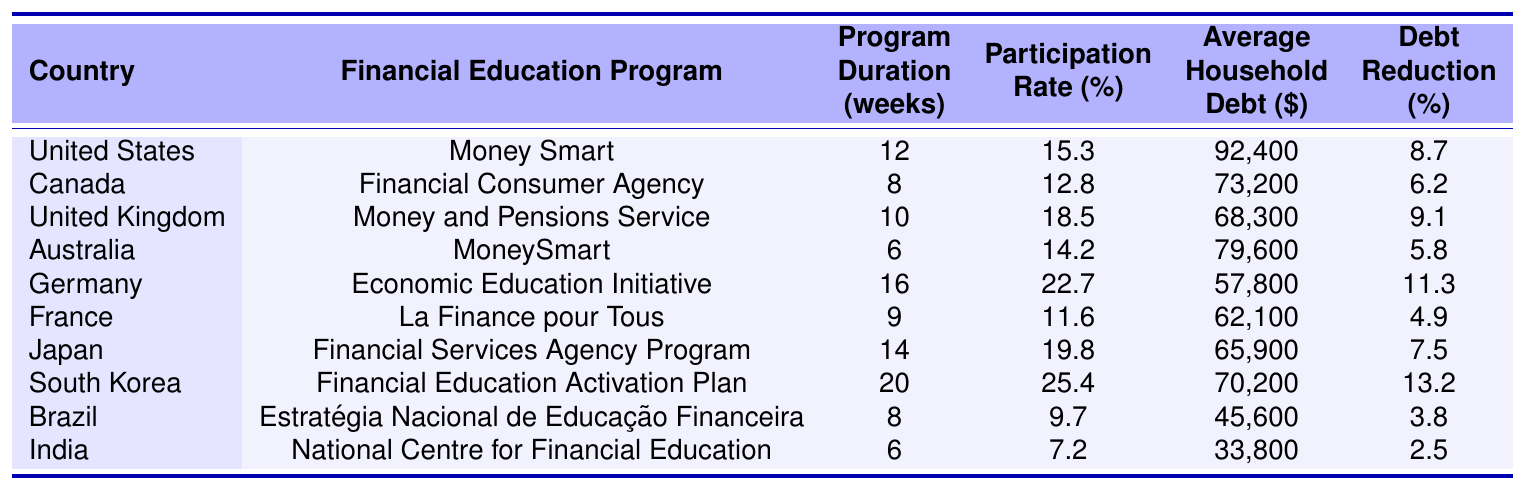What is the average household debt in Canada? According to the table, the average household debt in Canada is listed as $73,200.
Answer: $73,200 Which country has the highest participation rate in financial education programs? The table shows that South Korea has the highest participation rate at 25.4%.
Answer: 25.4% What is the program duration for the Financial Education Activation Plan in South Korea? The table indicates that the program duration for South Korea's Financial Education Activation Plan is 20 weeks.
Answer: 20 weeks Which two countries have an average household debt greater than $90,000? By examining the table, the United States and Australia are above $90,000, with debts of $92,400 and $79,600 respectively.
Answer: United States, Australia Which financial education program has the longest duration in weeks? The program with the longest duration is the Economic Education Initiative in Germany, lasting for 16 weeks.
Answer: 16 weeks True or False: The Debt Reduction percentage in Brazil is higher than that in France. The table shows that Brazil's Debt Reduction percentage is 3.8%, while France's is 4.9%. Hence, the statement is false.
Answer: False What is the average debt reduction percentage across all the countries listed? To find the average, sum all the debt reductions: (8.7 + 6.2 + 9.1 + 5.8 + 11.3 + 4.9 + 7.5 + 13.2 + 3.8 + 2.5) = 68.2%. Then divide by 10: 68.2 / 10 = 6.82%.
Answer: 6.82% Which country's financial education program has the shortest duration in weeks, and what is that duration? By scanning the table, it is evident that both Brazil and India have programs that last 6 weeks, which is the shortest duration.
Answer: Brazil, India; 6 weeks If a country reduces its household debt by 10% after a financial education program, what would the household debt in Canada be after this reduction? Canada's average household debt is $73,200. A 10% reduction would be calculated as follows: $73,200 - (0.10 * $73,200) = $73,200 - $7,320 = $65,880.
Answer: $65,880 Now, which country has the lowest average household debt? Looking at the table, India has the lowest average household debt listed as $33,800.
Answer: $33,800 